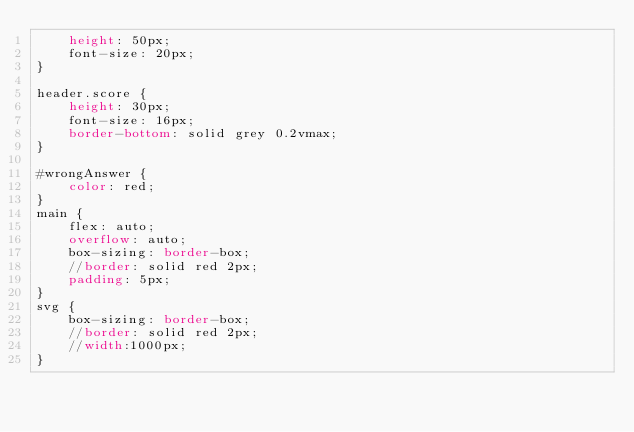<code> <loc_0><loc_0><loc_500><loc_500><_CSS_>    height: 50px;
    font-size: 20px;
}

header.score {
    height: 30px;
    font-size: 16px;
    border-bottom: solid grey 0.2vmax;
}

#wrongAnswer {
    color: red;
}
main {
    flex: auto;
    overflow: auto;
    box-sizing: border-box;
    //border: solid red 2px;
    padding: 5px;
}
svg {
    box-sizing: border-box;
    //border: solid red 2px;
    //width:1000px;
}</code> 